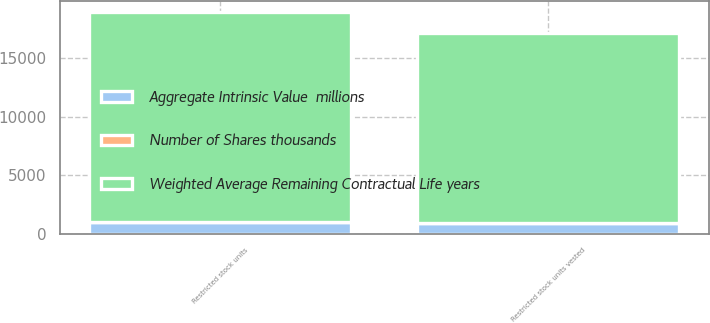Convert chart to OTSL. <chart><loc_0><loc_0><loc_500><loc_500><stacked_bar_chart><ecel><fcel>Restricted stock units<fcel>Restricted stock units vested<nl><fcel>Weighted Average Remaining Contractual Life years<fcel>17948<fcel>16265<nl><fcel>Number of Shares thousands<fcel>1.09<fcel>1.02<nl><fcel>Aggregate Intrinsic Value  millions<fcel>1019.1<fcel>920.5<nl></chart> 